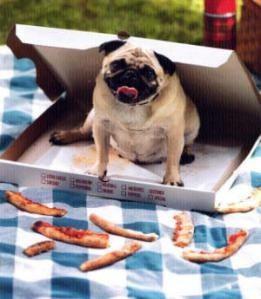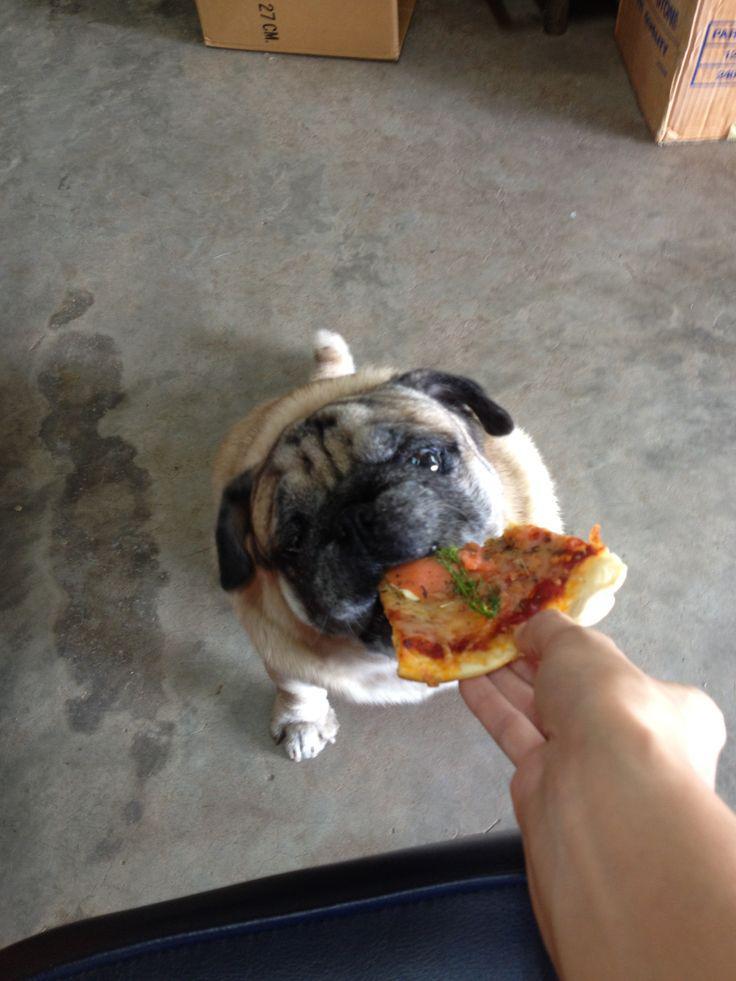The first image is the image on the left, the second image is the image on the right. For the images shown, is this caption "There is a pug eating a slice of pizza, and another pug not eating a slice of pizza." true? Answer yes or no. Yes. The first image is the image on the left, the second image is the image on the right. Assess this claim about the two images: "An image shows a pug with a propped elbow reclining in an open white box in front of stacks of white boxes.". Correct or not? Answer yes or no. No. 